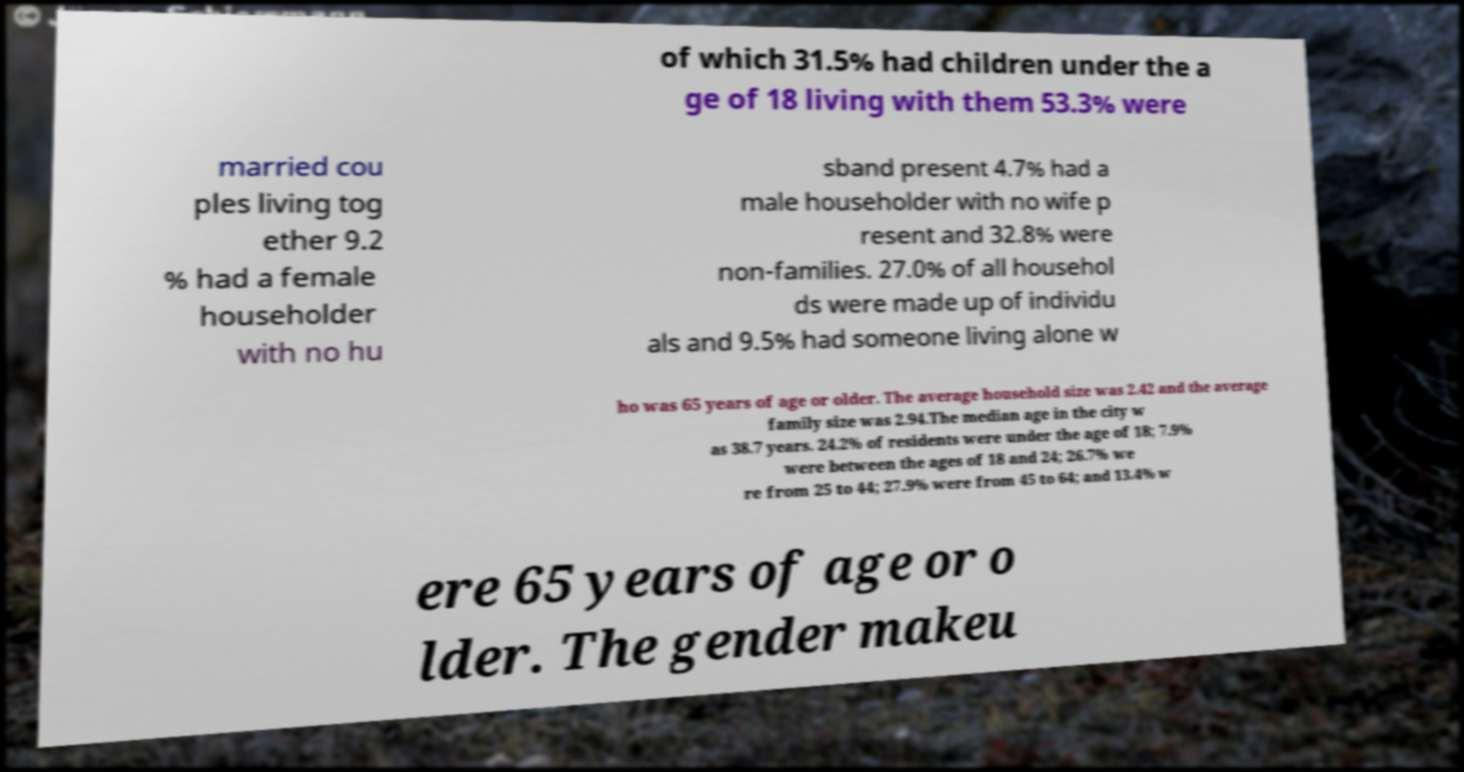For documentation purposes, I need the text within this image transcribed. Could you provide that? of which 31.5% had children under the a ge of 18 living with them 53.3% were married cou ples living tog ether 9.2 % had a female householder with no hu sband present 4.7% had a male householder with no wife p resent and 32.8% were non-families. 27.0% of all househol ds were made up of individu als and 9.5% had someone living alone w ho was 65 years of age or older. The average household size was 2.42 and the average family size was 2.94.The median age in the city w as 38.7 years. 24.2% of residents were under the age of 18; 7.9% were between the ages of 18 and 24; 26.7% we re from 25 to 44; 27.9% were from 45 to 64; and 13.4% w ere 65 years of age or o lder. The gender makeu 